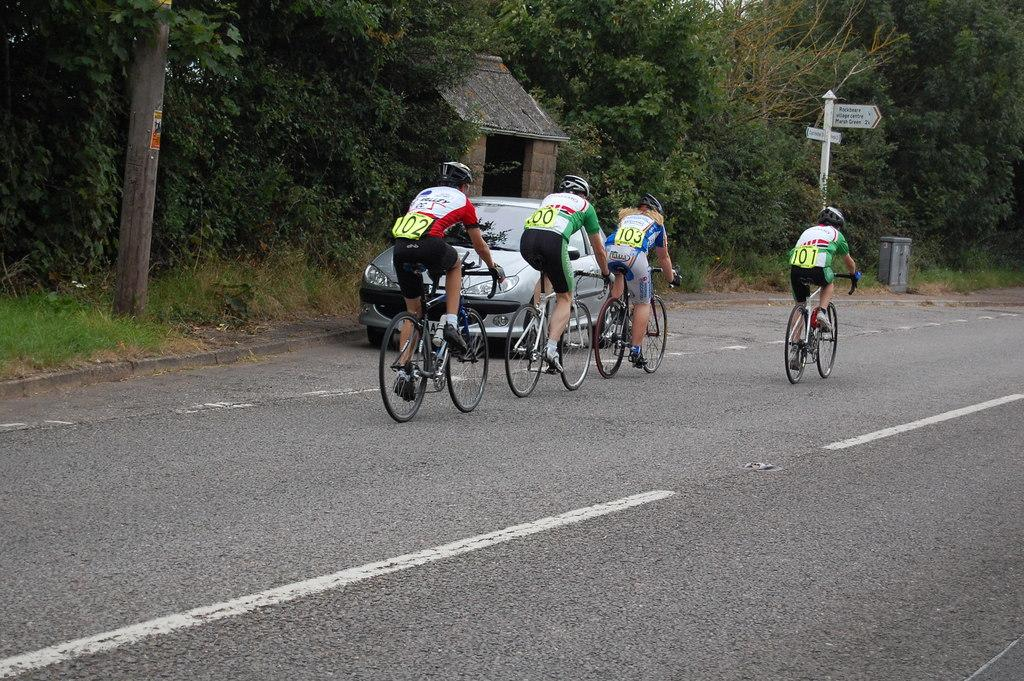How many cyclists are in the image? There are four persons cycling in the image. Where are the cyclists located? The cyclists are on the road. What else is on the road in the image? There is a car on the road. What can be seen in the background of the image? There is a roof for shelter, poles, and trees in the background. What type of fuel is the hydrant using in the image? There is no hydrant present in the image, so it is not possible to determine what type of fuel it might be using. What type of apparel are the cyclists wearing in the image? The provided facts do not mention the apparel of the cyclists, so it cannot be determined from the image. 